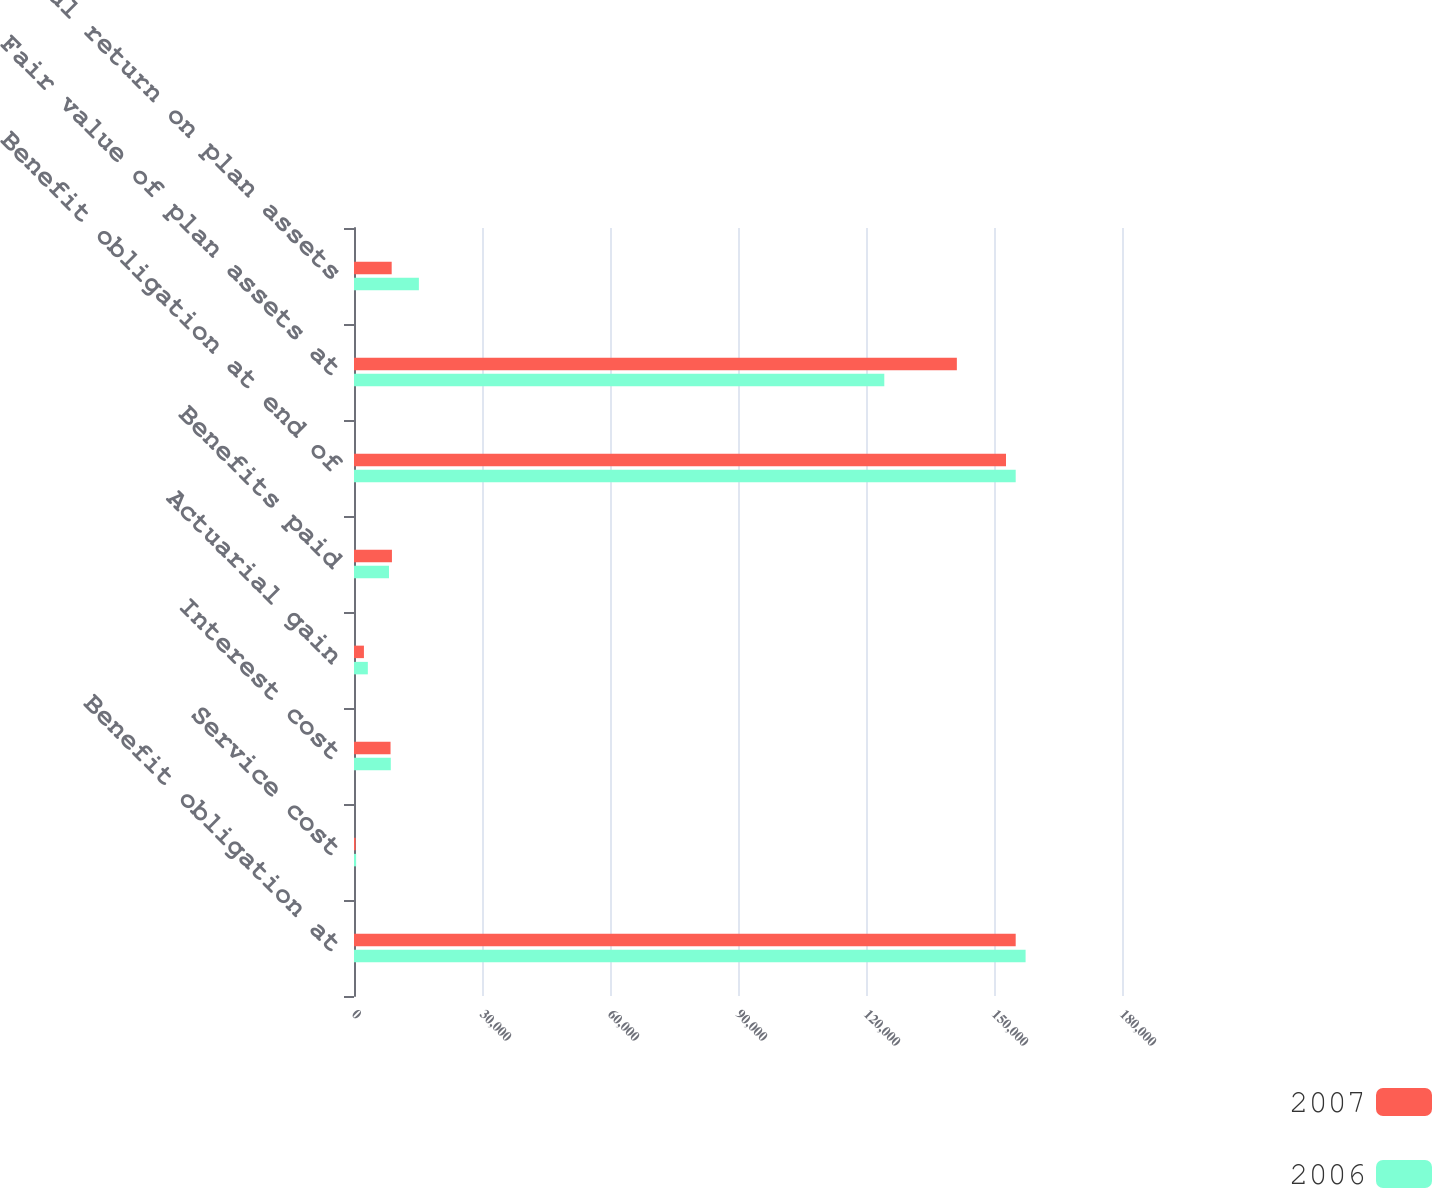Convert chart to OTSL. <chart><loc_0><loc_0><loc_500><loc_500><stacked_bar_chart><ecel><fcel>Benefit obligation at<fcel>Service cost<fcel>Interest cost<fcel>Actuarial gain<fcel>Benefits paid<fcel>Benefit obligation at end of<fcel>Fair value of plan assets at<fcel>Actual return on plan assets<nl><fcel>2007<fcel>155084<fcel>384<fcel>8564<fcel>2328<fcel>8891<fcel>152813<fcel>141294<fcel>8832<nl><fcel>2006<fcel>157404<fcel>499<fcel>8624<fcel>3242<fcel>8201<fcel>155084<fcel>124288<fcel>15207<nl></chart> 